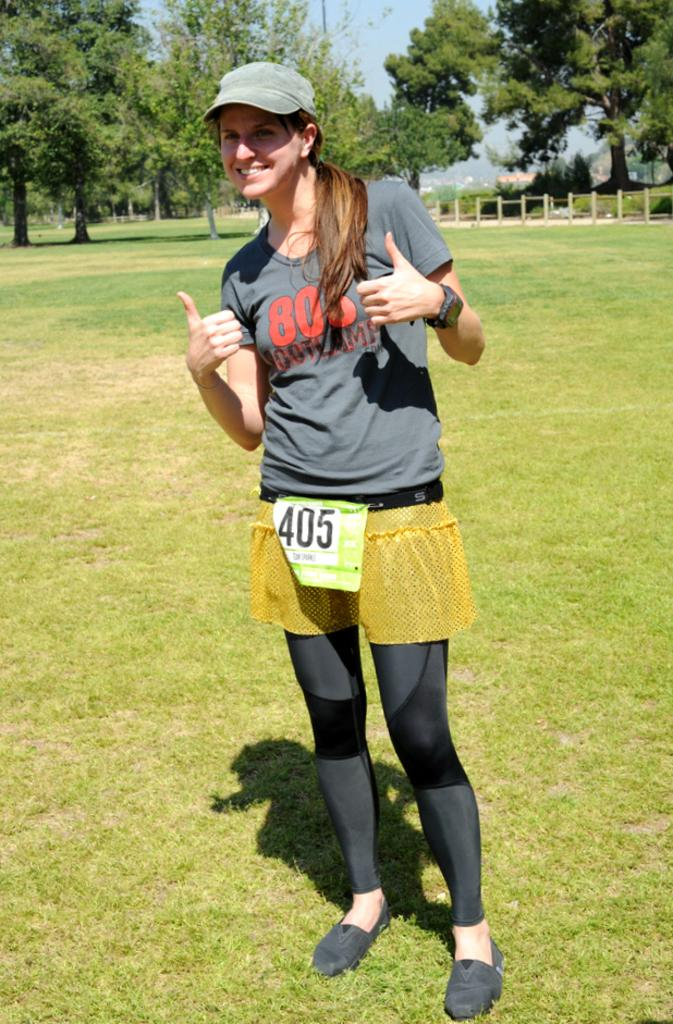Who is the main subject in the image? There is a woman in the image. What is the woman wearing? The woman is wearing a black dress. Where is the woman standing? The woman is standing on the ground. What type of natural environment is visible in the image? There are trees visible in the image. What can be seen in the background of the image? The sky is visible in the background of the image. How many oranges are being recited in verse by the woman in the image? There are no oranges or any reference to verses in the image; the woman is simply standing in a natural environment. 